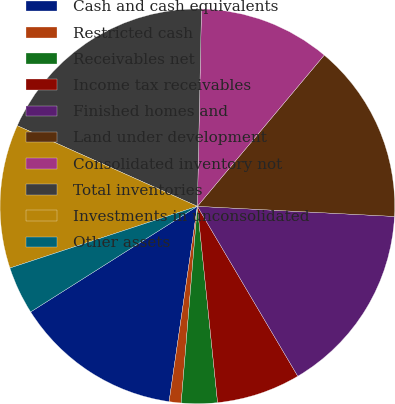<chart> <loc_0><loc_0><loc_500><loc_500><pie_chart><fcel>Cash and cash equivalents<fcel>Restricted cash<fcel>Receivables net<fcel>Income tax receivables<fcel>Finished homes and<fcel>Land under development<fcel>Consolidated inventory not<fcel>Total inventories<fcel>Investments in unconsolidated<fcel>Other assets<nl><fcel>13.72%<fcel>0.98%<fcel>2.94%<fcel>6.86%<fcel>15.68%<fcel>14.7%<fcel>10.78%<fcel>18.62%<fcel>11.76%<fcel>3.92%<nl></chart> 